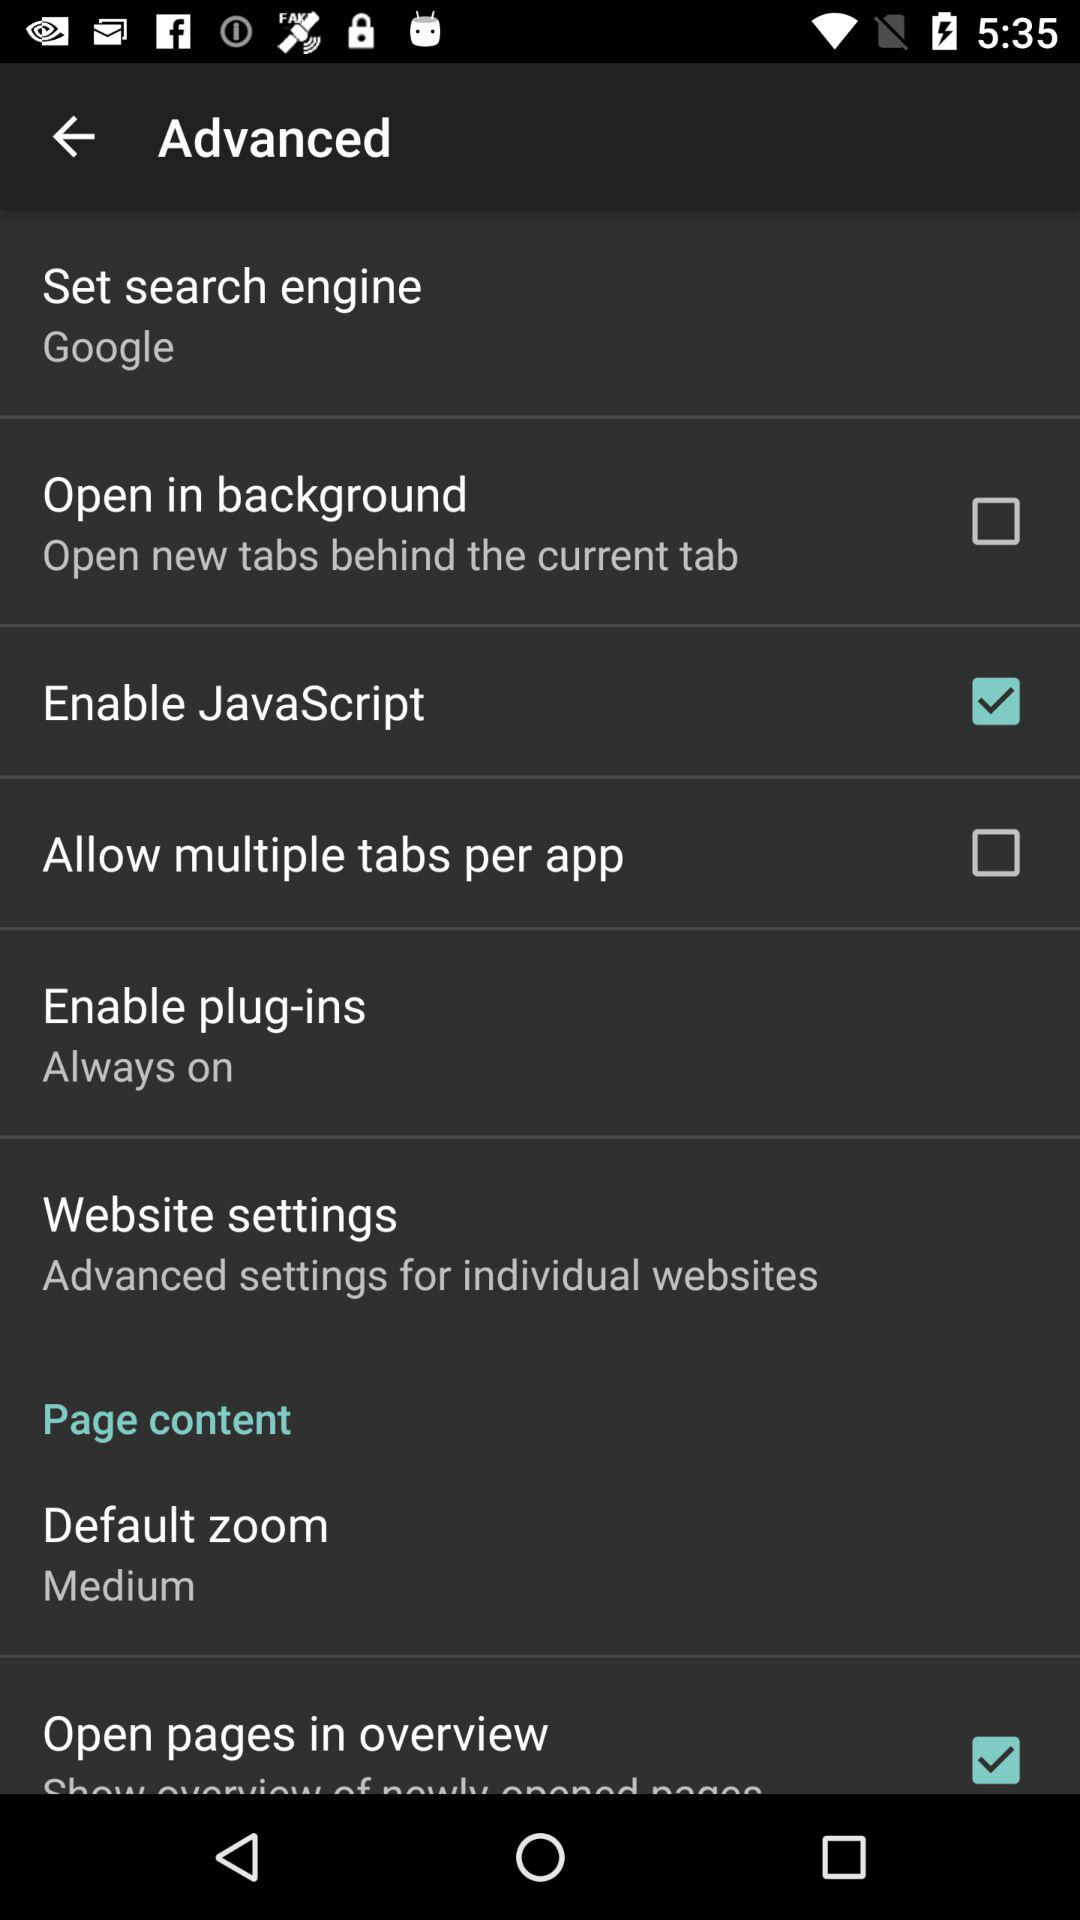What are the individually listed website addresses?
When the provided information is insufficient, respond with <no answer>. <no answer> 